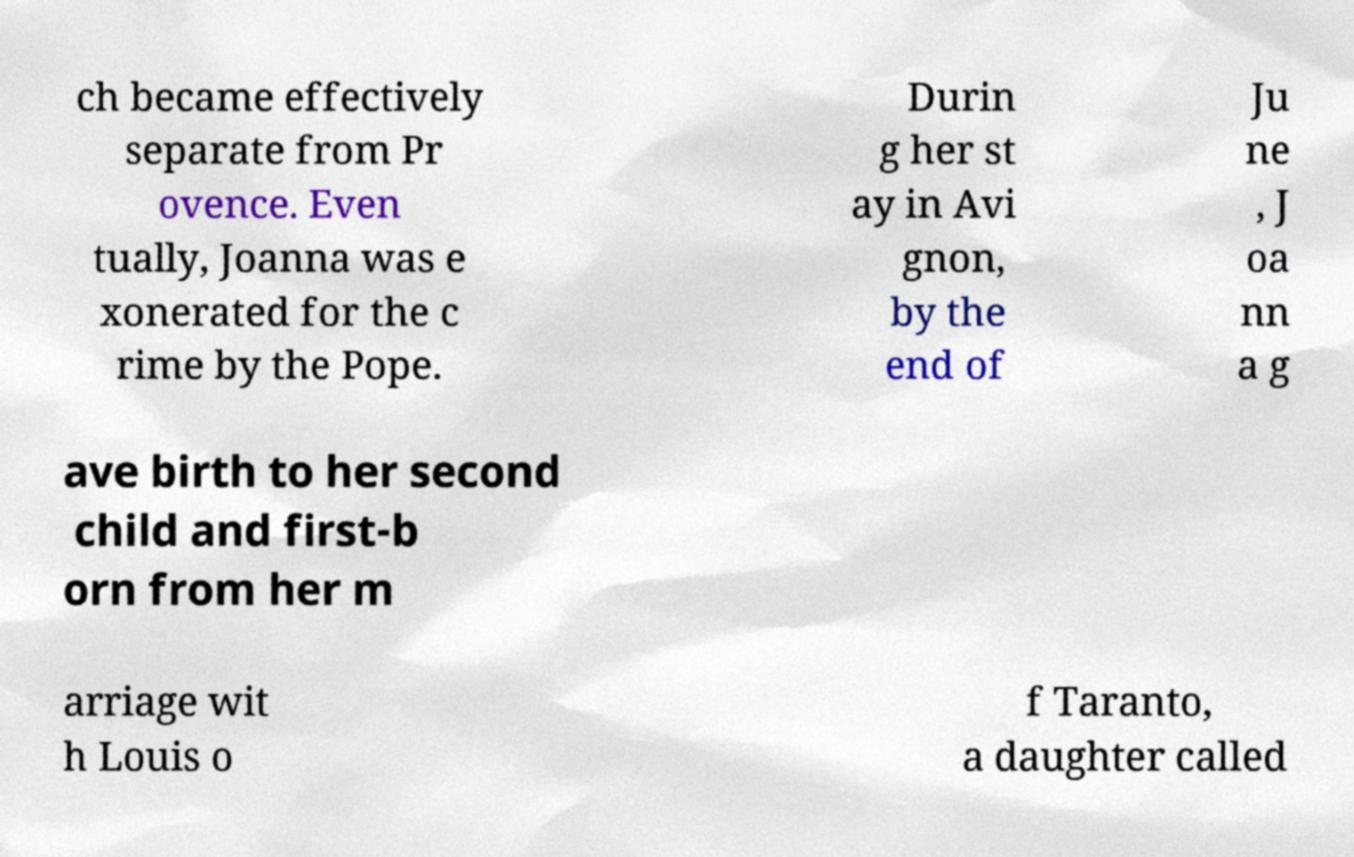Please read and relay the text visible in this image. What does it say? ch became effectively separate from Pr ovence. Even tually, Joanna was e xonerated for the c rime by the Pope. Durin g her st ay in Avi gnon, by the end of Ju ne , J oa nn a g ave birth to her second child and first-b orn from her m arriage wit h Louis o f Taranto, a daughter called 